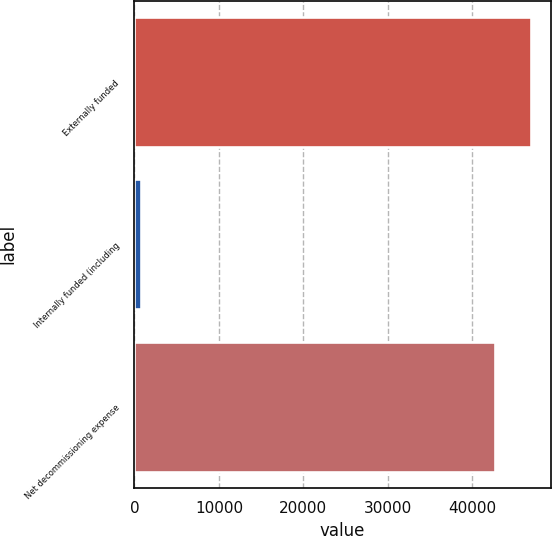<chart> <loc_0><loc_0><loc_500><loc_500><bar_chart><fcel>Externally funded<fcel>Internally funded (including<fcel>Net decommissioning expense<nl><fcel>46896.3<fcel>759<fcel>42633<nl></chart> 